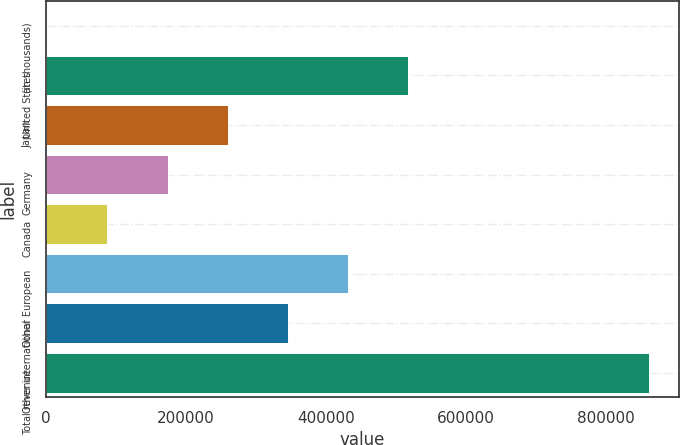<chart> <loc_0><loc_0><loc_500><loc_500><bar_chart><fcel>(in thousands)<fcel>United States<fcel>Japan<fcel>Germany<fcel>Canada<fcel>Other European<fcel>Other international<fcel>Total revenue<nl><fcel>2013<fcel>517561<fcel>259787<fcel>173862<fcel>87937.7<fcel>431636<fcel>345712<fcel>861260<nl></chart> 